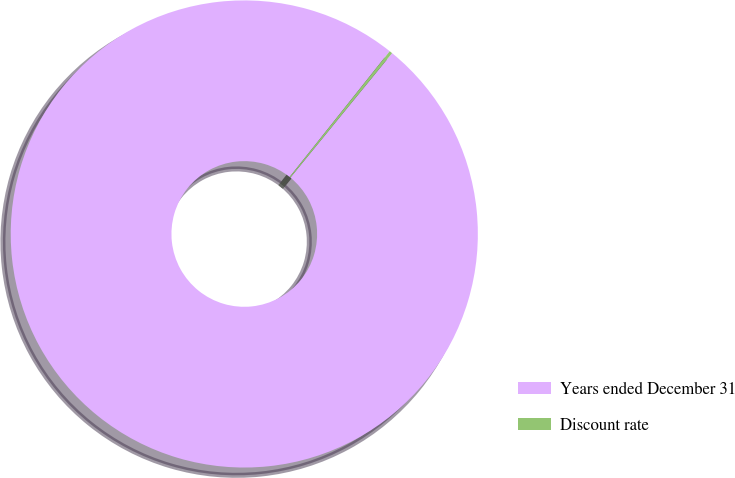Convert chart. <chart><loc_0><loc_0><loc_500><loc_500><pie_chart><fcel>Years ended December 31<fcel>Discount rate<nl><fcel>99.79%<fcel>0.21%<nl></chart> 